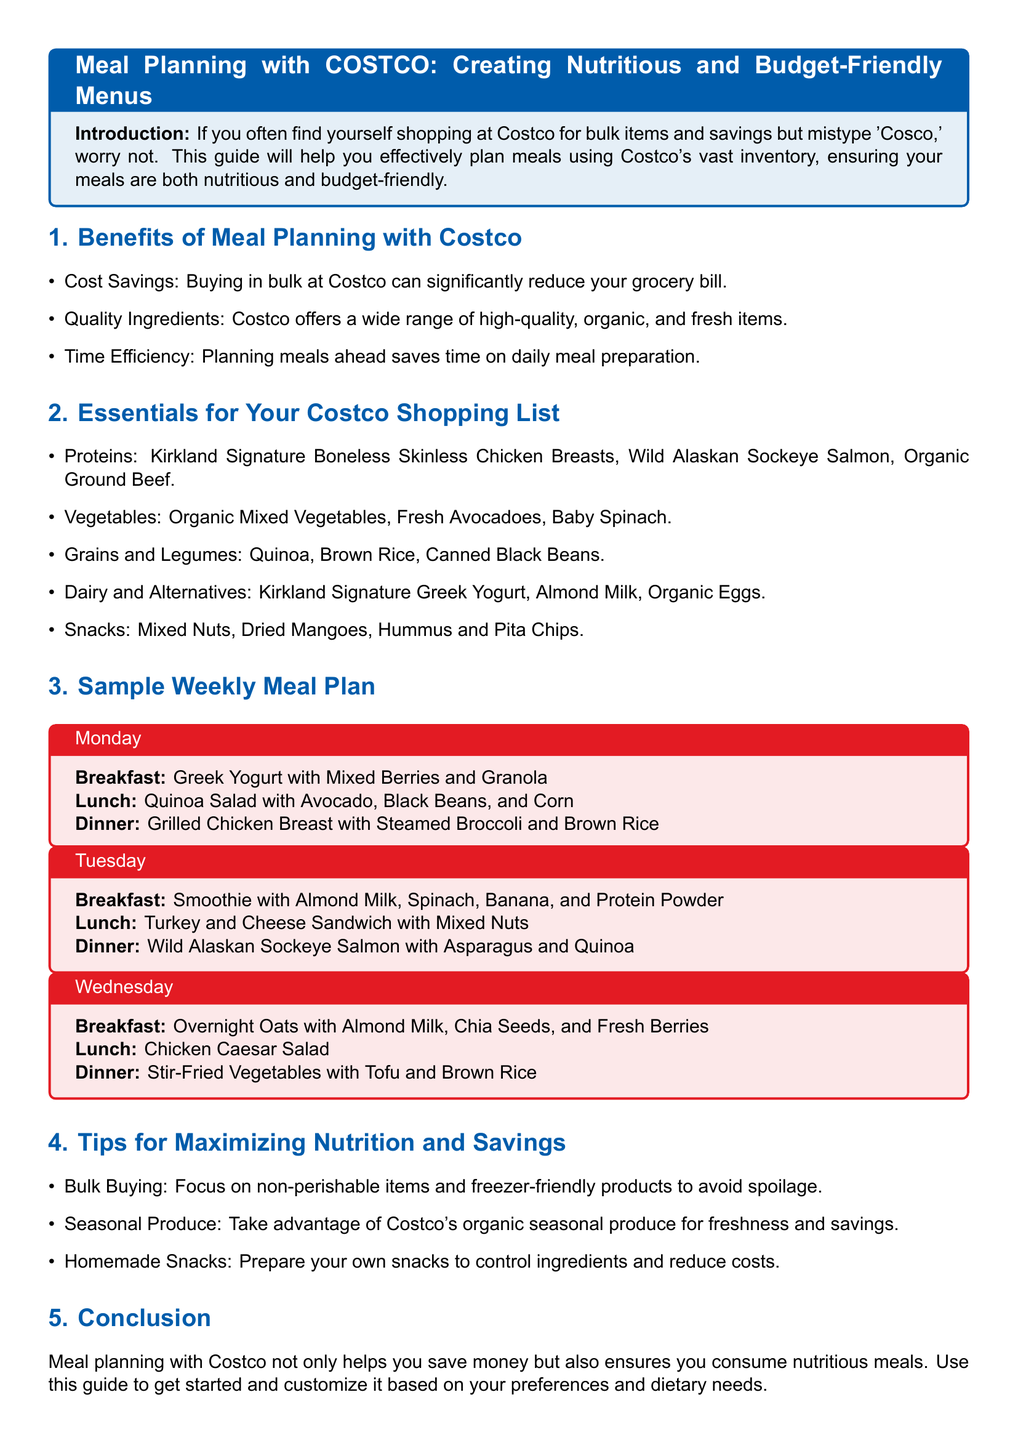what is the title of the guide? The title of the guide is stated clearly at the beginning of the document.
Answer: Meal Planning with COSTCO: Creating Nutritious and Budget-Friendly Menus what is a benefit of meal planning with Costco? The document lists several benefits in the first section, including cost savings.
Answer: Cost Savings what protein is mentioned in the essentials list? The document includes a list of proteins in the essentials section.
Answer: Kirkland Signature Boneless Skinless Chicken Breasts how many days are covered in the sample weekly meal plan? The sample weekly meal plan includes entries for three specific days.
Answer: 3 what is a key tip for maximizing nutrition mentioned in the document? The document provides tips for maximizing nutrition, such as focusing on bulk buying.
Answer: Bulk Buying what dish is suggested for Monday's dinner? The specific dinner suggestion for Monday is detailed in the meal plan.
Answer: Grilled Chicken Breast with Steamed Broccoli and Brown Rice which day features a smoothie for breakfast? The breakfast options listed in the meal plan include a smoothie on a specific day.
Answer: Tuesday what type of produce should you take advantage of for savings? The document mentions maximizing savings through a particular type of produce.
Answer: Seasonal Produce what is the conclusion of the guide focused on? The conclusion summarizes the advantages of meal planning discussed throughout the document.
Answer: Save money and ensure nutritious meals 